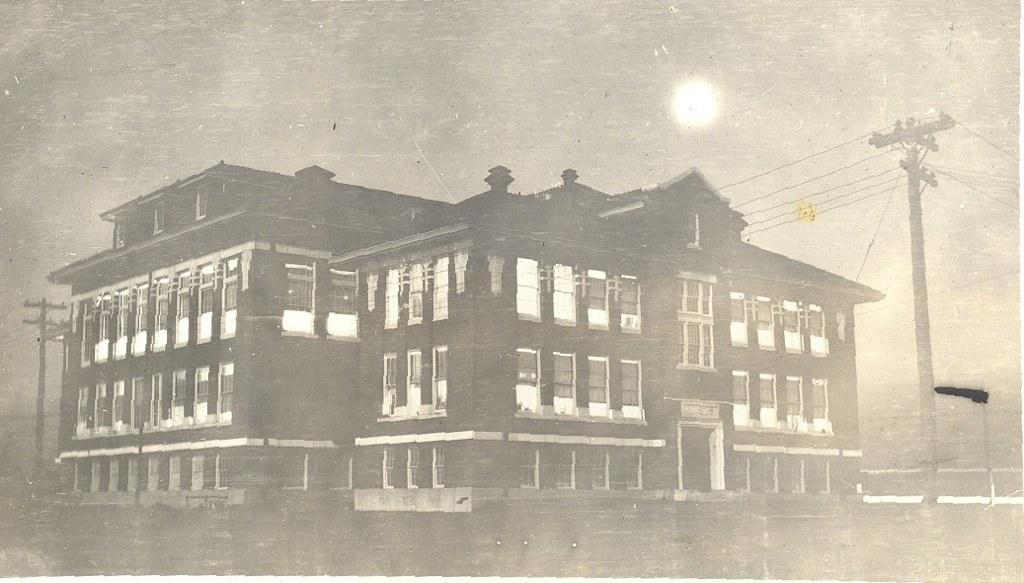What type of structure is present in the image? There is a building in the image. What else can be seen in the image besides the building? There are poles in the image. What is visible at the top of the image? The sun is visible at the top of the image. What type of substance is being cut with a knife in the image? There is no knife or substance present in the image. How much salt is visible in the image? There is no salt present in the image. 